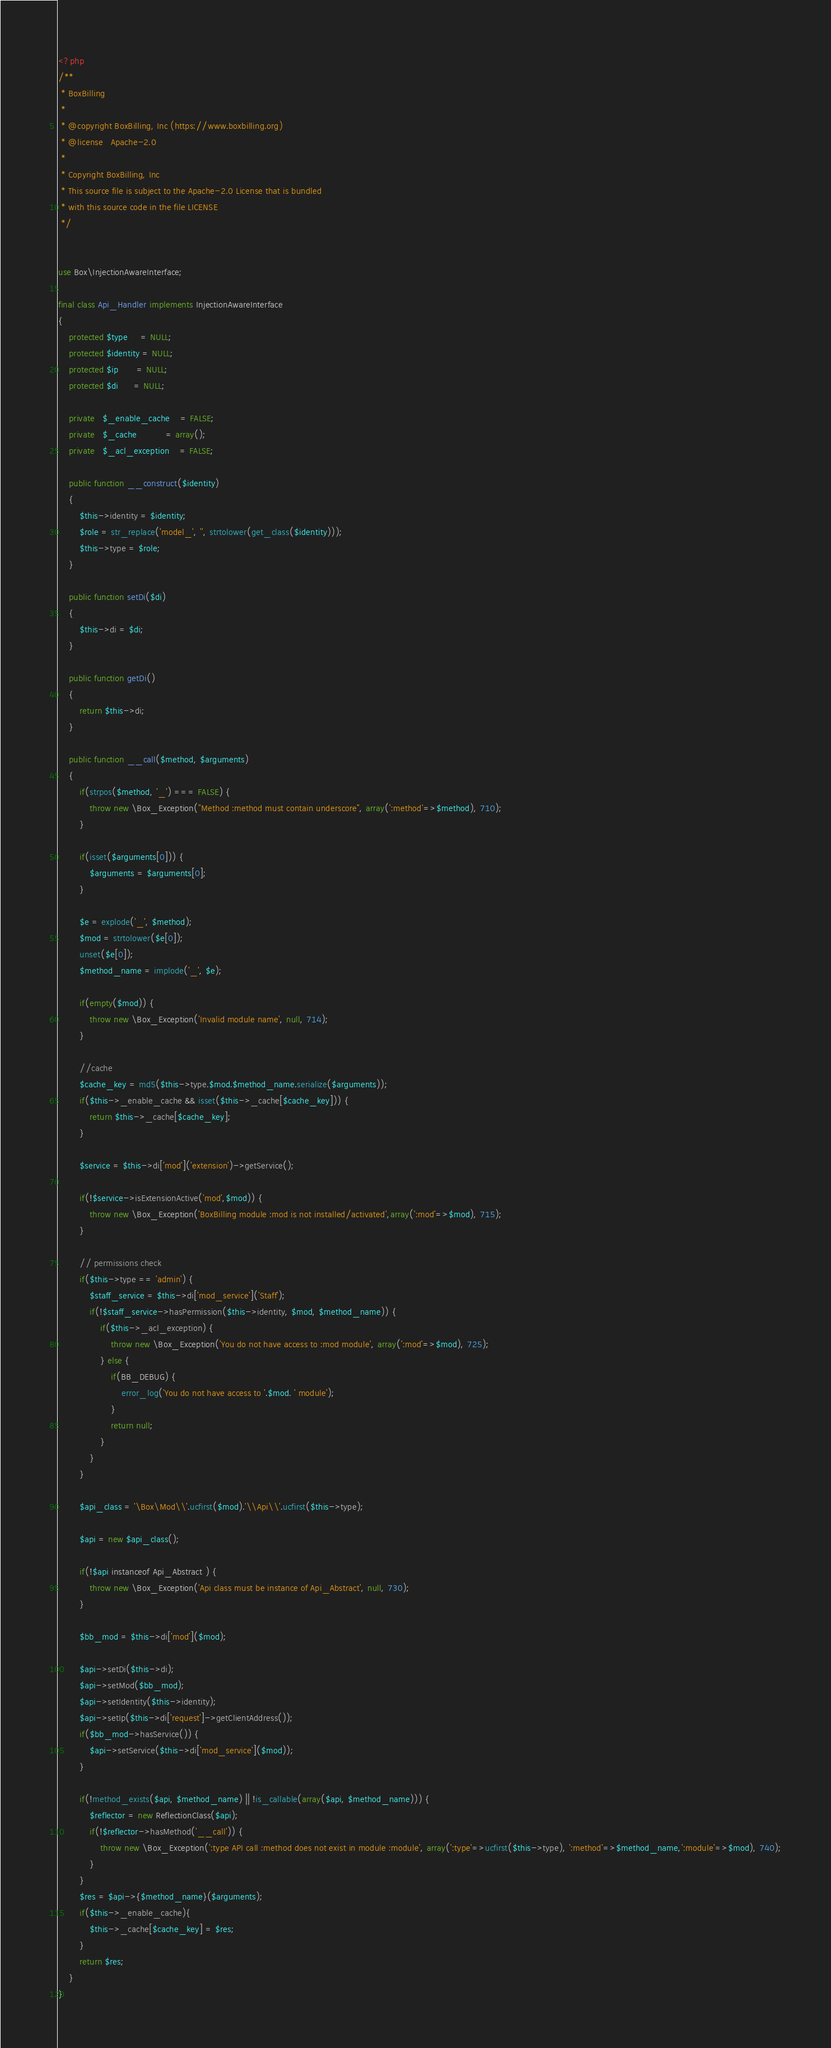<code> <loc_0><loc_0><loc_500><loc_500><_PHP_><?php
/**
 * BoxBilling
 *
 * @copyright BoxBilling, Inc (https://www.boxbilling.org)
 * @license   Apache-2.0
 *
 * Copyright BoxBilling, Inc
 * This source file is subject to the Apache-2.0 License that is bundled
 * with this source code in the file LICENSE
 */


use Box\InjectionAwareInterface;

final class Api_Handler implements InjectionAwareInterface
{
    protected $type     = NULL;
    protected $identity = NULL;
    protected $ip       = NULL;
    protected $di      = NULL;

    private   $_enable_cache    = FALSE;
    private   $_cache           = array();
    private   $_acl_exception    = FALSE;
    
    public function __construct($identity)
    {
        $this->identity = $identity;
        $role = str_replace('model_', '', strtolower(get_class($identity)));
        $this->type = $role;
    }

    public function setDi($di)
    {
        $this->di = $di;
    }

    public function getDi()
    {
        return $this->di;
    }

    public function __call($method, $arguments)
    {
        if(strpos($method, '_') === FALSE) {
            throw new \Box_Exception("Method :method must contain underscore", array(':method'=>$method), 710);
        }

        if(isset($arguments[0])) {
            $arguments = $arguments[0];
        }

        $e = explode('_', $method);
        $mod = strtolower($e[0]);
        unset($e[0]);
        $method_name = implode('_', $e);
        
        if(empty($mod)) {
            throw new \Box_Exception('Invalid module name', null, 714);
        }
        
        //cache
        $cache_key = md5($this->type.$mod.$method_name.serialize($arguments));
        if($this->_enable_cache && isset($this->_cache[$cache_key])) {
            return $this->_cache[$cache_key];
        }

        $service = $this->di['mod']('extension')->getService();

        if(!$service->isExtensionActive('mod',$mod)) {
            throw new \Box_Exception('BoxBilling module :mod is not installed/activated',array(':mod'=>$mod), 715);
        }

        // permissions check
        if($this->type == 'admin') {
            $staff_service = $this->di['mod_service']('Staff');
            if(!$staff_service->hasPermission($this->identity, $mod, $method_name)) {
                if($this->_acl_exception) {
                    throw new \Box_Exception('You do not have access to :mod module', array(':mod'=>$mod), 725);
                } else {
                    if(BB_DEBUG) {
                        error_log('You do not have access to '.$mod. ' module');
                    }
                    return null;
                }
            }
        }

        $api_class = '\Box\Mod\\'.ucfirst($mod).'\\Api\\'.ucfirst($this->type);

        $api = new $api_class();

        if(!$api instanceof Api_Abstract ) {
            throw new \Box_Exception('Api class must be instance of Api_Abstract', null, 730);
        }

        $bb_mod = $this->di['mod']($mod);

        $api->setDi($this->di);
        $api->setMod($bb_mod);
        $api->setIdentity($this->identity);
        $api->setIp($this->di['request']->getClientAddress());
        if($bb_mod->hasService()) {
            $api->setService($this->di['mod_service']($mod));
        }

        if(!method_exists($api, $method_name) || !is_callable(array($api, $method_name))) {
            $reflector = new ReflectionClass($api);
            if(!$reflector->hasMethod('__call')) {
                throw new \Box_Exception(':type API call :method does not exist in module :module', array(':type'=>ucfirst($this->type), ':method'=>$method_name,':module'=>$mod), 740);
            }
        }
        $res = $api->{$method_name}($arguments);
        if($this->_enable_cache){
            $this->_cache[$cache_key] = $res;
        }
        return $res;
    }
}</code> 